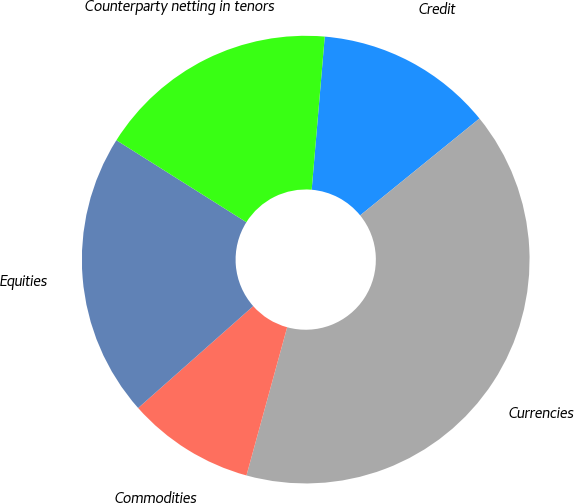Convert chart. <chart><loc_0><loc_0><loc_500><loc_500><pie_chart><fcel>Credit<fcel>Currencies<fcel>Commodities<fcel>Equities<fcel>Counterparty netting in tenors<nl><fcel>12.79%<fcel>40.12%<fcel>9.2%<fcel>20.49%<fcel>17.4%<nl></chart> 